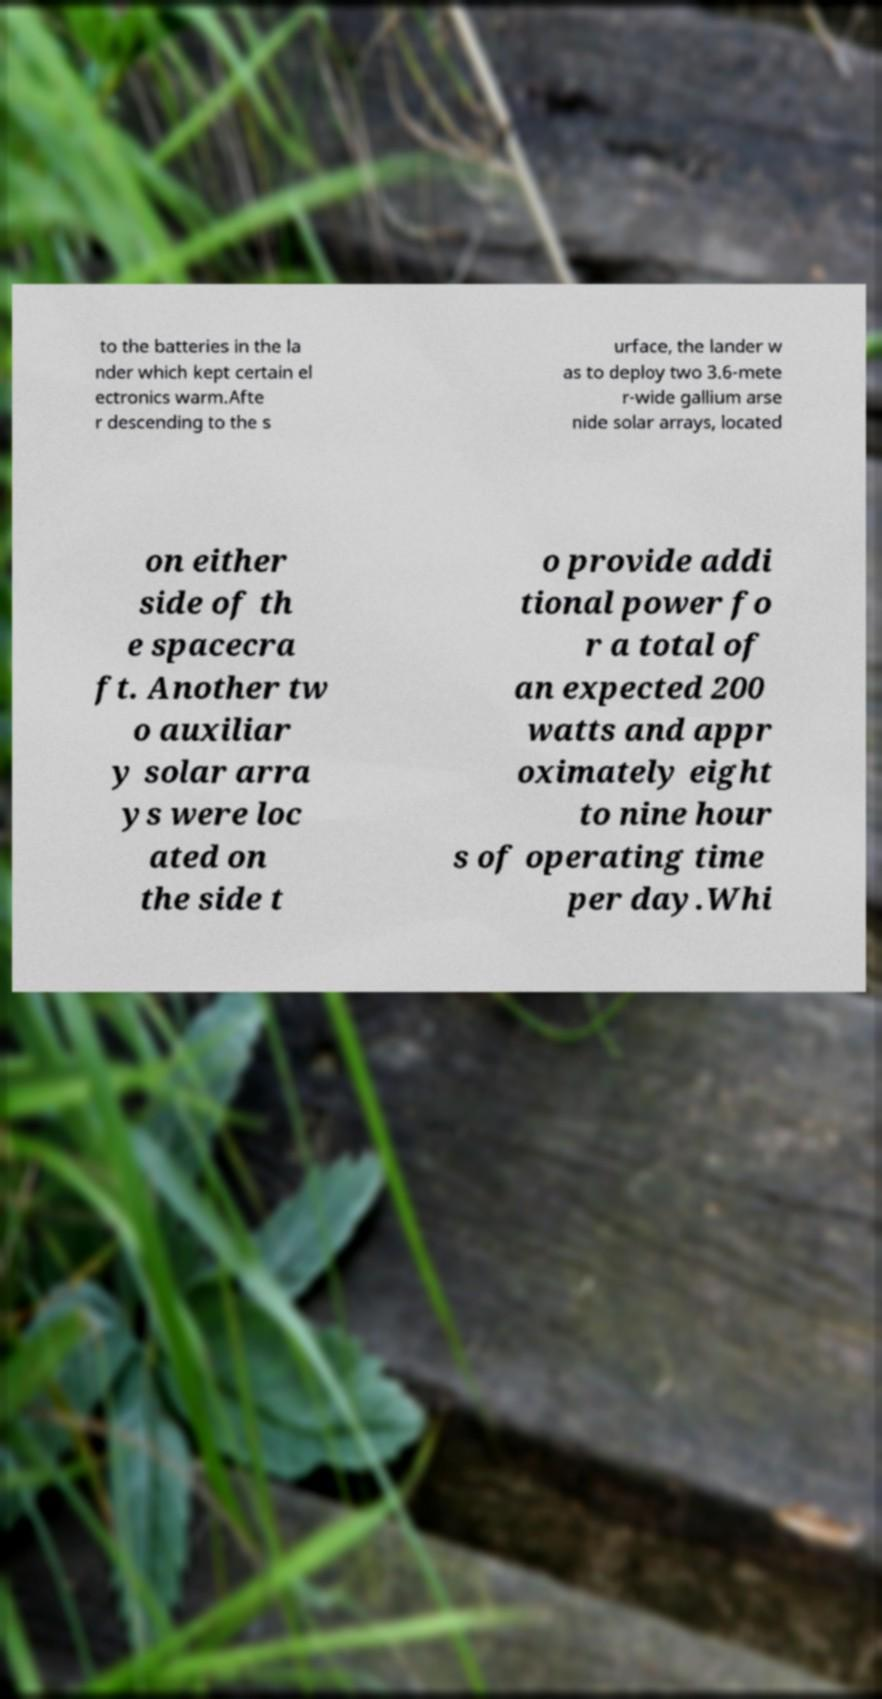Please read and relay the text visible in this image. What does it say? to the batteries in the la nder which kept certain el ectronics warm.Afte r descending to the s urface, the lander w as to deploy two 3.6-mete r-wide gallium arse nide solar arrays, located on either side of th e spacecra ft. Another tw o auxiliar y solar arra ys were loc ated on the side t o provide addi tional power fo r a total of an expected 200 watts and appr oximately eight to nine hour s of operating time per day.Whi 